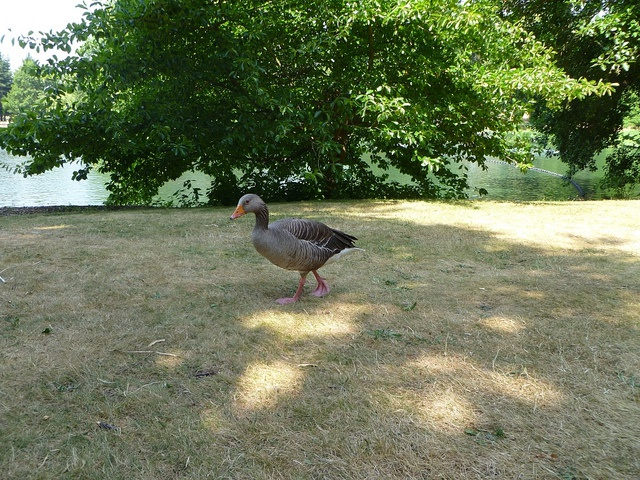Describe the objects in this image and their specific colors. I can see a bird in white, gray, black, and maroon tones in this image. 